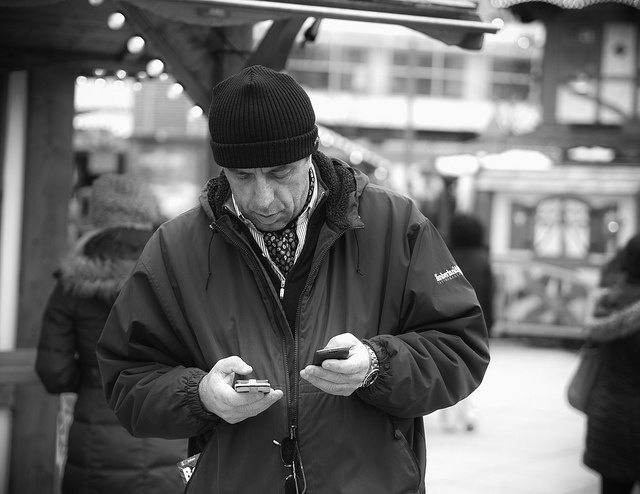Describe the objects in this image and their specific colors. I can see people in black, gray, darkgray, and lightgray tones, people in black, gray, and lightgray tones, people in black, gray, darkgray, and lightgray tones, people in black and gray tones, and handbag in black, gray, darkgray, and lightgray tones in this image. 